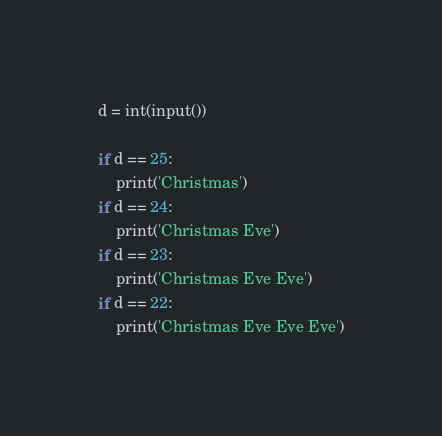Convert code to text. <code><loc_0><loc_0><loc_500><loc_500><_Python_>d = int(input())

if d == 25:
    print('Christmas')
if d == 24:
    print('Christmas Eve')
if d == 23:
    print('Christmas Eve Eve')
if d == 22:
    print('Christmas Eve Eve Eve')
</code> 